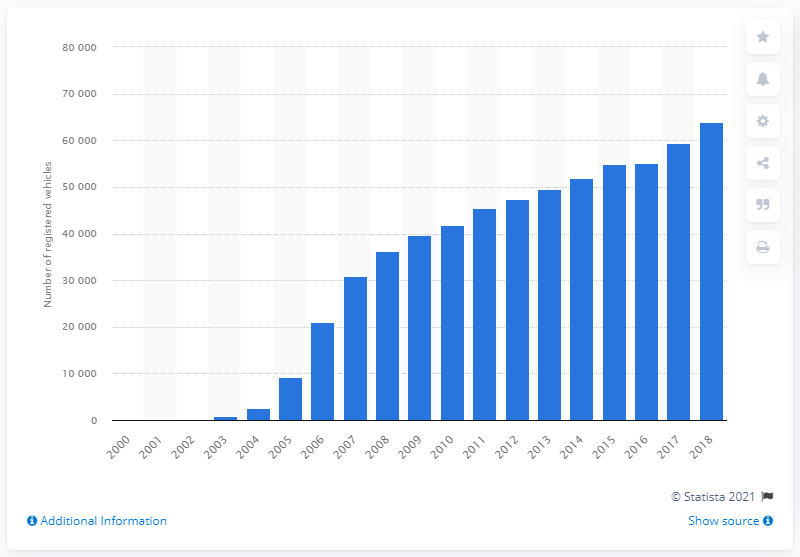Draw attention to some important aspects in this diagram. By the end of 2018, a total of 63,912 registered vehicles were reported. 